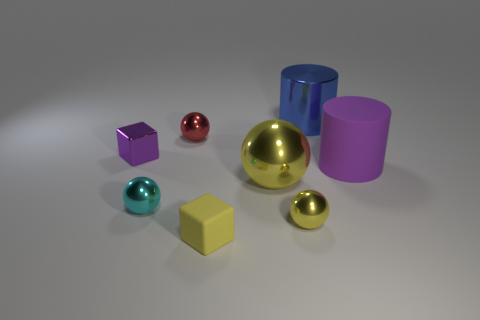How many yellow rubber cubes are behind the yellow object that is behind the tiny metallic thing on the right side of the tiny yellow rubber object?
Your answer should be compact. 0. There is a matte thing in front of the purple rubber thing; what is its color?
Provide a short and direct response. Yellow. Does the cylinder in front of the small red shiny sphere have the same color as the rubber block?
Keep it short and to the point. No. What size is the other thing that is the same shape as the yellow matte thing?
Keep it short and to the point. Small. Is there anything else that is the same size as the red metal thing?
Your answer should be compact. Yes. What is the block that is behind the matte object to the left of the rubber object right of the large blue cylinder made of?
Offer a terse response. Metal. Are there more purple objects that are behind the big shiny cylinder than blue metallic cylinders that are in front of the tiny purple metal thing?
Your answer should be very brief. No. Does the purple metallic thing have the same size as the purple rubber cylinder?
Give a very brief answer. No. The other tiny thing that is the same shape as the yellow matte thing is what color?
Offer a very short reply. Purple. What number of tiny metallic objects have the same color as the small rubber block?
Your answer should be compact. 1. 